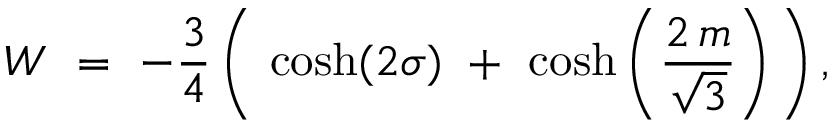<formula> <loc_0><loc_0><loc_500><loc_500>W = - { \frac { 3 } { 4 } } \, \left ( \, \cosh ( 2 \sigma ) + \cosh \left ( { \frac { 2 \, m } { \sqrt { 3 } } } \right ) \, \right ) \, ,</formula> 